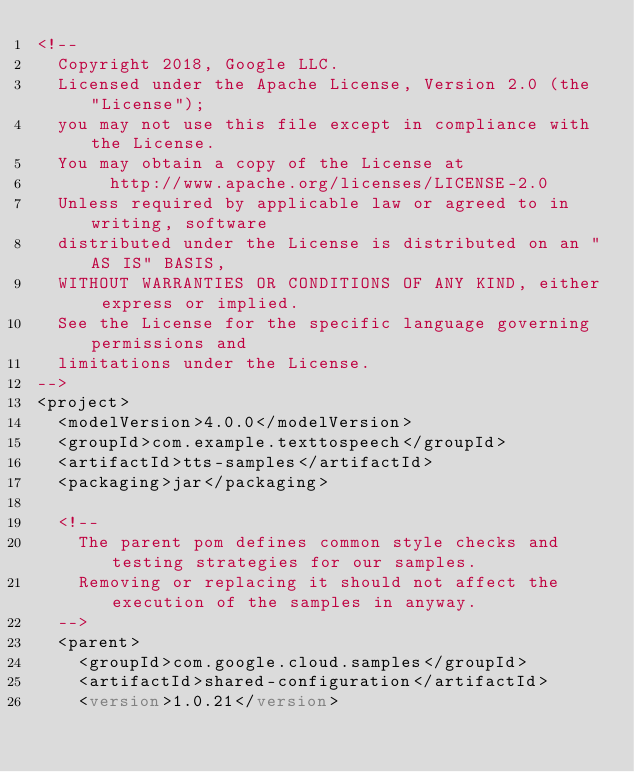<code> <loc_0><loc_0><loc_500><loc_500><_XML_><!--
  Copyright 2018, Google LLC.
  Licensed under the Apache License, Version 2.0 (the "License");
  you may not use this file except in compliance with the License.
  You may obtain a copy of the License at
       http://www.apache.org/licenses/LICENSE-2.0
  Unless required by applicable law or agreed to in writing, software
  distributed under the License is distributed on an "AS IS" BASIS,
  WITHOUT WARRANTIES OR CONDITIONS OF ANY KIND, either express or implied.
  See the License for the specific language governing permissions and
  limitations under the License.
-->
<project>
  <modelVersion>4.0.0</modelVersion>
  <groupId>com.example.texttospeech</groupId>
  <artifactId>tts-samples</artifactId>
  <packaging>jar</packaging>

  <!--
    The parent pom defines common style checks and testing strategies for our samples.
    Removing or replacing it should not affect the execution of the samples in anyway.
  -->
  <parent>
    <groupId>com.google.cloud.samples</groupId>
    <artifactId>shared-configuration</artifactId>
    <version>1.0.21</version></code> 